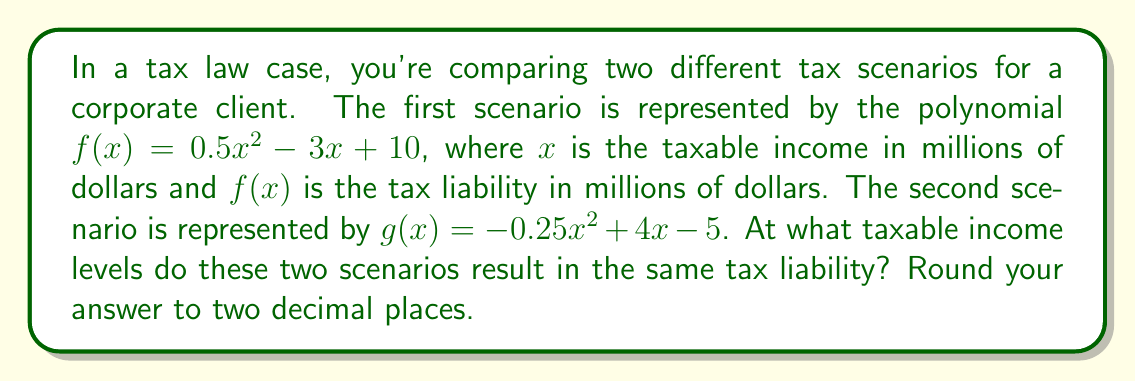Can you solve this math problem? To find the intersection points of these two polynomial curves, we need to solve the equation $f(x) = g(x)$:

1) Set up the equation:
   $0.5x^2 - 3x + 10 = -0.25x^2 + 4x - 5$

2) Rearrange all terms to one side:
   $0.5x^2 - 3x + 10 + 0.25x^2 - 4x + 5 = 0$

3) Simplify:
   $0.75x^2 - 7x + 15 = 0$

4) Multiply all terms by 4 to eliminate fractions:
   $3x^2 - 28x + 60 = 0$

5) This is a quadratic equation. We can solve it using the quadratic formula:
   $x = \frac{-b \pm \sqrt{b^2 - 4ac}}{2a}$

   Where $a = 3$, $b = -28$, and $c = 60$

6) Substitute into the quadratic formula:
   $x = \frac{28 \pm \sqrt{(-28)^2 - 4(3)(60)}}{2(3)}$

7) Simplify:
   $x = \frac{28 \pm \sqrt{784 - 720}}{6} = \frac{28 \pm \sqrt{64}}{6} = \frac{28 \pm 8}{6}$

8) Calculate the two solutions:
   $x_1 = \frac{28 + 8}{6} = \frac{36}{6} = 6$
   $x_2 = \frac{28 - 8}{6} = \frac{20}{6} = 3.33$ (rounded to 2 decimal places)

Therefore, the two scenarios result in the same tax liability when the taxable income is $6$ million dollars or $3.33$ million dollars.
Answer: $3.33$ million and $6$ million 